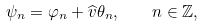Convert formula to latex. <formula><loc_0><loc_0><loc_500><loc_500>\psi _ { n } = \varphi _ { n } + \widehat { v } \theta _ { n } , \quad n \in \mathbb { Z } ,</formula> 